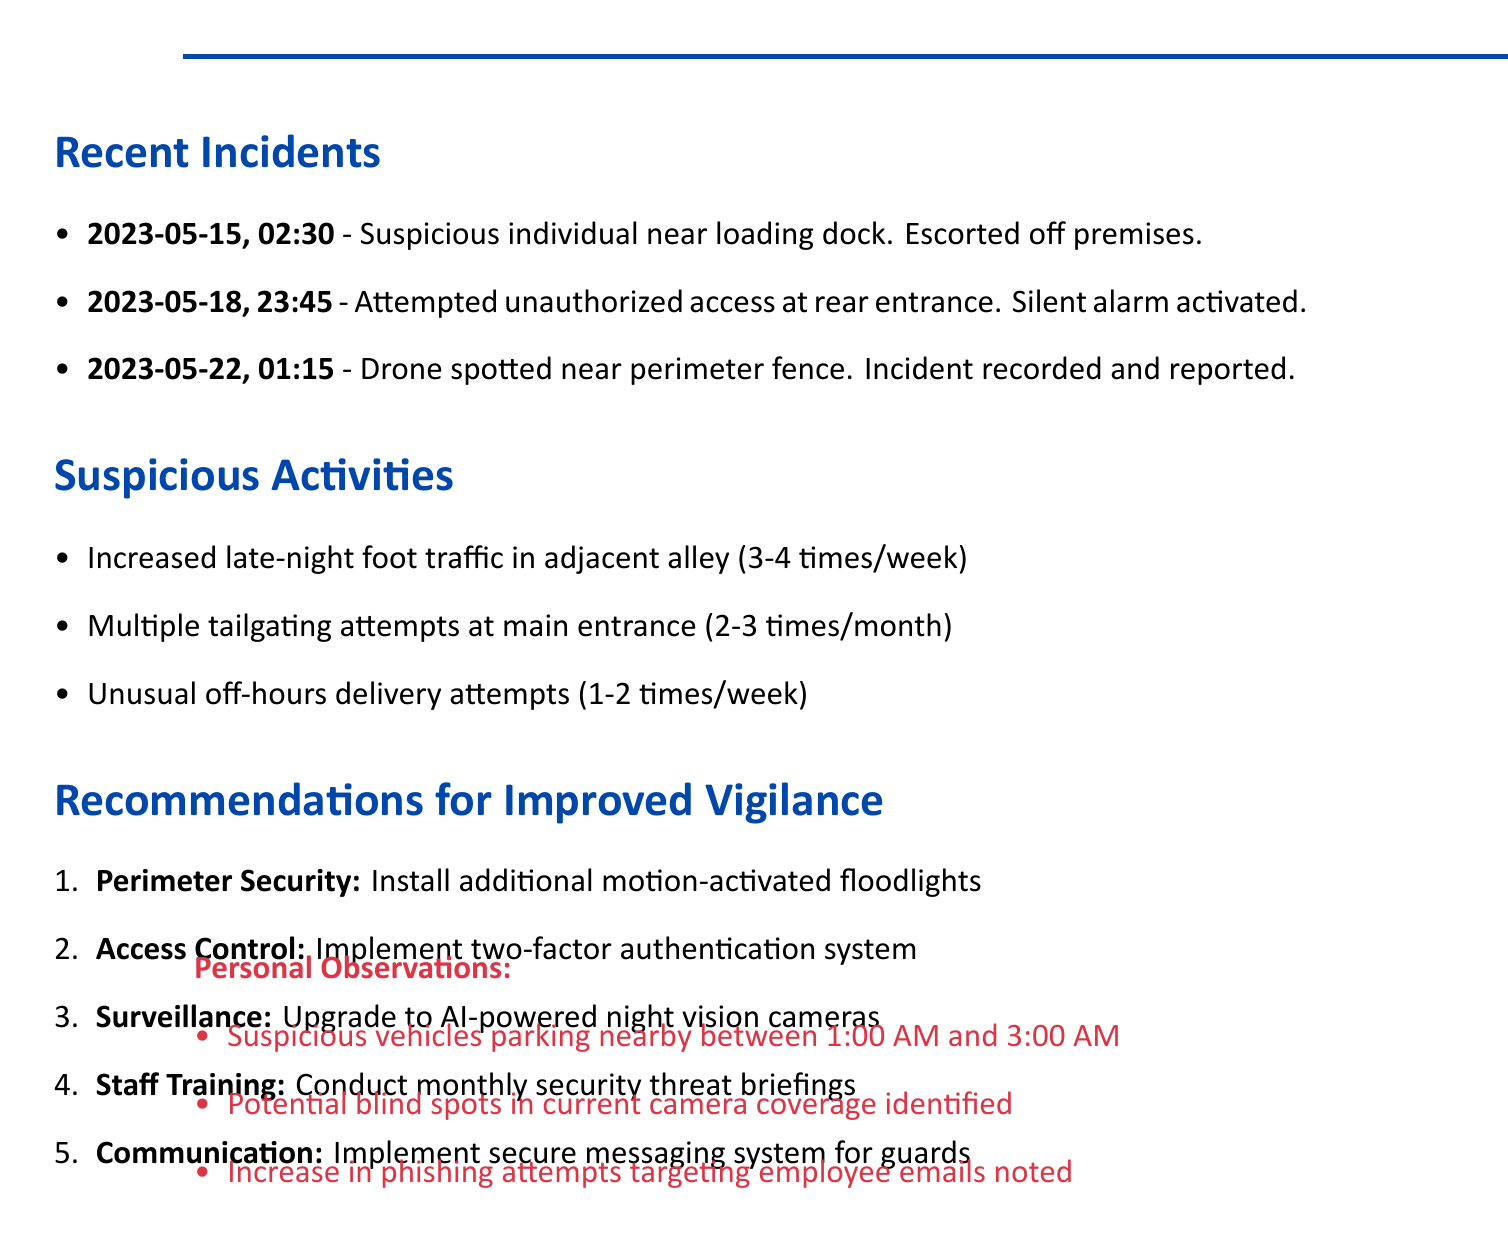What date did the suspicious individual loitering incident occur? The document lists the date of the incident as May 15, 2023.
Answer: May 15, 2023 How many suspicious activities are noted in the document? The document lists a total of three suspicious activities observed.
Answer: 3 What action was taken during the attempted unauthorized access? The document states that the silent alarm was activated and local law enforcement was contacted.
Answer: Activated silent alarm What frequency is noted for increased foot traffic in the adjacent alley? The document specifies that increased foot traffic is observed 3-4 times per week.
Answer: 3-4 times per week What recommendation is made for perimeter security? The document recommends installing additional motion-activated floodlights along the fence line.
Answer: Install additional motion-activated floodlights What observation was made about phishing attempts? The document mentions an increase in phishing attempts targeting employees' work emails.
Answer: Increase in phishing attempts What is the benefit of upgrading to high-resolution night vision cameras? The benefit stated is enhanced ability to detect and respond to suspicious activities in real-time.
Answer: Enhanced ability to detect and respond to suspicious activities How many incidents were recorded on May 22, 2023? The document records one incident on this date involving a drone.
Answer: 1 What is the recommendation related to staff training? The recommendation is to conduct monthly briefings on emerging security threats and countermeasures.
Answer: Conduct monthly briefings on emerging security threats 